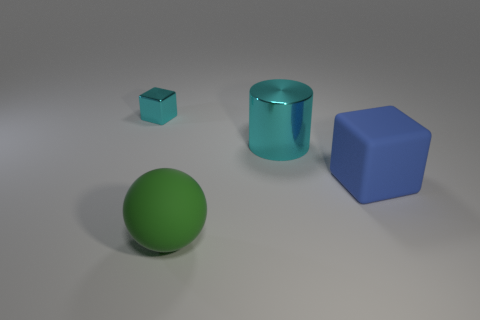What number of objects are both on the right side of the tiny cyan metallic thing and behind the matte ball?
Ensure brevity in your answer.  2. The metallic object that is the same color as the cylinder is what shape?
Offer a terse response. Cube. What is the material of the thing that is in front of the cylinder and to the right of the large green rubber sphere?
Your answer should be very brief. Rubber. Are there fewer cyan things that are in front of the rubber sphere than tiny shiny things to the right of the small cyan metallic block?
Your answer should be compact. No. What is the size of the green thing that is the same material as the blue cube?
Keep it short and to the point. Large. Is there anything else of the same color as the big rubber block?
Give a very brief answer. No. Do the blue thing and the cyan thing right of the large green rubber sphere have the same material?
Make the answer very short. No. There is another blue thing that is the same shape as the small object; what is it made of?
Your answer should be compact. Rubber. Are there any other things that have the same material as the green thing?
Make the answer very short. Yes. Do the cyan thing that is left of the green ball and the cube to the right of the sphere have the same material?
Offer a terse response. No. 